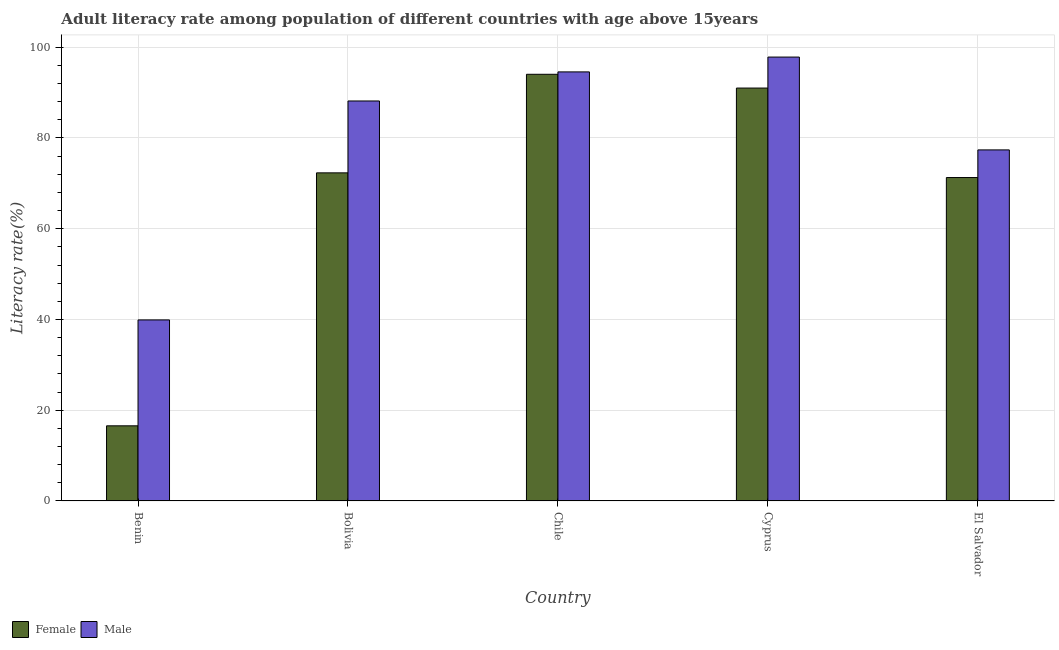How many bars are there on the 4th tick from the left?
Give a very brief answer. 2. How many bars are there on the 1st tick from the right?
Provide a succinct answer. 2. In how many cases, is the number of bars for a given country not equal to the number of legend labels?
Offer a terse response. 0. What is the female adult literacy rate in Chile?
Give a very brief answer. 94.04. Across all countries, what is the maximum female adult literacy rate?
Ensure brevity in your answer.  94.04. Across all countries, what is the minimum male adult literacy rate?
Keep it short and to the point. 39.9. In which country was the male adult literacy rate maximum?
Give a very brief answer. Cyprus. In which country was the male adult literacy rate minimum?
Make the answer very short. Benin. What is the total male adult literacy rate in the graph?
Your answer should be compact. 397.82. What is the difference between the male adult literacy rate in Benin and that in Bolivia?
Your answer should be compact. -48.25. What is the difference between the female adult literacy rate in Bolivia and the male adult literacy rate in El Salvador?
Your answer should be very brief. -5.06. What is the average male adult literacy rate per country?
Offer a terse response. 79.56. What is the difference between the female adult literacy rate and male adult literacy rate in Benin?
Provide a short and direct response. -23.34. In how many countries, is the male adult literacy rate greater than 48 %?
Give a very brief answer. 4. What is the ratio of the female adult literacy rate in Bolivia to that in Cyprus?
Your response must be concise. 0.79. Is the female adult literacy rate in Bolivia less than that in Chile?
Ensure brevity in your answer.  Yes. What is the difference between the highest and the second highest male adult literacy rate?
Your response must be concise. 3.27. What is the difference between the highest and the lowest male adult literacy rate?
Give a very brief answer. 57.93. In how many countries, is the female adult literacy rate greater than the average female adult literacy rate taken over all countries?
Your response must be concise. 4. How many countries are there in the graph?
Your answer should be very brief. 5. What is the difference between two consecutive major ticks on the Y-axis?
Provide a succinct answer. 20. Where does the legend appear in the graph?
Your response must be concise. Bottom left. How are the legend labels stacked?
Your answer should be very brief. Horizontal. What is the title of the graph?
Ensure brevity in your answer.  Adult literacy rate among population of different countries with age above 15years. What is the label or title of the Y-axis?
Provide a succinct answer. Literacy rate(%). What is the Literacy rate(%) in Female in Benin?
Your response must be concise. 16.57. What is the Literacy rate(%) in Male in Benin?
Your answer should be compact. 39.9. What is the Literacy rate(%) in Female in Bolivia?
Provide a short and direct response. 72.31. What is the Literacy rate(%) in Male in Bolivia?
Your answer should be compact. 88.16. What is the Literacy rate(%) of Female in Chile?
Provide a short and direct response. 94.04. What is the Literacy rate(%) of Male in Chile?
Give a very brief answer. 94.56. What is the Literacy rate(%) of Female in Cyprus?
Keep it short and to the point. 91. What is the Literacy rate(%) of Male in Cyprus?
Offer a very short reply. 97.83. What is the Literacy rate(%) in Female in El Salvador?
Your response must be concise. 71.28. What is the Literacy rate(%) in Male in El Salvador?
Your answer should be very brief. 77.37. Across all countries, what is the maximum Literacy rate(%) of Female?
Give a very brief answer. 94.04. Across all countries, what is the maximum Literacy rate(%) of Male?
Offer a very short reply. 97.83. Across all countries, what is the minimum Literacy rate(%) in Female?
Offer a very short reply. 16.57. Across all countries, what is the minimum Literacy rate(%) in Male?
Offer a very short reply. 39.9. What is the total Literacy rate(%) of Female in the graph?
Give a very brief answer. 345.2. What is the total Literacy rate(%) of Male in the graph?
Your response must be concise. 397.82. What is the difference between the Literacy rate(%) of Female in Benin and that in Bolivia?
Give a very brief answer. -55.75. What is the difference between the Literacy rate(%) in Male in Benin and that in Bolivia?
Your answer should be very brief. -48.25. What is the difference between the Literacy rate(%) of Female in Benin and that in Chile?
Provide a short and direct response. -77.47. What is the difference between the Literacy rate(%) of Male in Benin and that in Chile?
Ensure brevity in your answer.  -54.66. What is the difference between the Literacy rate(%) of Female in Benin and that in Cyprus?
Offer a terse response. -74.44. What is the difference between the Literacy rate(%) of Male in Benin and that in Cyprus?
Make the answer very short. -57.93. What is the difference between the Literacy rate(%) in Female in Benin and that in El Salvador?
Make the answer very short. -54.72. What is the difference between the Literacy rate(%) in Male in Benin and that in El Salvador?
Provide a succinct answer. -37.47. What is the difference between the Literacy rate(%) in Female in Bolivia and that in Chile?
Provide a succinct answer. -21.72. What is the difference between the Literacy rate(%) in Male in Bolivia and that in Chile?
Give a very brief answer. -6.41. What is the difference between the Literacy rate(%) of Female in Bolivia and that in Cyprus?
Your response must be concise. -18.69. What is the difference between the Literacy rate(%) of Male in Bolivia and that in Cyprus?
Your response must be concise. -9.68. What is the difference between the Literacy rate(%) of Female in Bolivia and that in El Salvador?
Ensure brevity in your answer.  1.03. What is the difference between the Literacy rate(%) of Male in Bolivia and that in El Salvador?
Make the answer very short. 10.78. What is the difference between the Literacy rate(%) in Female in Chile and that in Cyprus?
Provide a short and direct response. 3.03. What is the difference between the Literacy rate(%) in Male in Chile and that in Cyprus?
Provide a short and direct response. -3.27. What is the difference between the Literacy rate(%) of Female in Chile and that in El Salvador?
Your answer should be very brief. 22.76. What is the difference between the Literacy rate(%) in Male in Chile and that in El Salvador?
Provide a succinct answer. 17.19. What is the difference between the Literacy rate(%) of Female in Cyprus and that in El Salvador?
Offer a terse response. 19.72. What is the difference between the Literacy rate(%) in Male in Cyprus and that in El Salvador?
Your answer should be very brief. 20.46. What is the difference between the Literacy rate(%) in Female in Benin and the Literacy rate(%) in Male in Bolivia?
Provide a succinct answer. -71.59. What is the difference between the Literacy rate(%) of Female in Benin and the Literacy rate(%) of Male in Chile?
Ensure brevity in your answer.  -78. What is the difference between the Literacy rate(%) of Female in Benin and the Literacy rate(%) of Male in Cyprus?
Your answer should be compact. -81.27. What is the difference between the Literacy rate(%) in Female in Benin and the Literacy rate(%) in Male in El Salvador?
Offer a terse response. -60.81. What is the difference between the Literacy rate(%) of Female in Bolivia and the Literacy rate(%) of Male in Chile?
Provide a succinct answer. -22.25. What is the difference between the Literacy rate(%) in Female in Bolivia and the Literacy rate(%) in Male in Cyprus?
Your response must be concise. -25.52. What is the difference between the Literacy rate(%) of Female in Bolivia and the Literacy rate(%) of Male in El Salvador?
Your response must be concise. -5.06. What is the difference between the Literacy rate(%) of Female in Chile and the Literacy rate(%) of Male in Cyprus?
Offer a very short reply. -3.79. What is the difference between the Literacy rate(%) in Female in Chile and the Literacy rate(%) in Male in El Salvador?
Make the answer very short. 16.66. What is the difference between the Literacy rate(%) of Female in Cyprus and the Literacy rate(%) of Male in El Salvador?
Your answer should be compact. 13.63. What is the average Literacy rate(%) in Female per country?
Ensure brevity in your answer.  69.04. What is the average Literacy rate(%) of Male per country?
Your answer should be compact. 79.56. What is the difference between the Literacy rate(%) in Female and Literacy rate(%) in Male in Benin?
Ensure brevity in your answer.  -23.34. What is the difference between the Literacy rate(%) in Female and Literacy rate(%) in Male in Bolivia?
Your answer should be compact. -15.84. What is the difference between the Literacy rate(%) of Female and Literacy rate(%) of Male in Chile?
Offer a very short reply. -0.53. What is the difference between the Literacy rate(%) in Female and Literacy rate(%) in Male in Cyprus?
Provide a succinct answer. -6.83. What is the difference between the Literacy rate(%) of Female and Literacy rate(%) of Male in El Salvador?
Make the answer very short. -6.09. What is the ratio of the Literacy rate(%) in Female in Benin to that in Bolivia?
Give a very brief answer. 0.23. What is the ratio of the Literacy rate(%) of Male in Benin to that in Bolivia?
Offer a very short reply. 0.45. What is the ratio of the Literacy rate(%) in Female in Benin to that in Chile?
Offer a very short reply. 0.18. What is the ratio of the Literacy rate(%) in Male in Benin to that in Chile?
Provide a short and direct response. 0.42. What is the ratio of the Literacy rate(%) of Female in Benin to that in Cyprus?
Your answer should be compact. 0.18. What is the ratio of the Literacy rate(%) in Male in Benin to that in Cyprus?
Make the answer very short. 0.41. What is the ratio of the Literacy rate(%) in Female in Benin to that in El Salvador?
Your response must be concise. 0.23. What is the ratio of the Literacy rate(%) of Male in Benin to that in El Salvador?
Your response must be concise. 0.52. What is the ratio of the Literacy rate(%) of Female in Bolivia to that in Chile?
Provide a succinct answer. 0.77. What is the ratio of the Literacy rate(%) in Male in Bolivia to that in Chile?
Provide a short and direct response. 0.93. What is the ratio of the Literacy rate(%) in Female in Bolivia to that in Cyprus?
Provide a succinct answer. 0.79. What is the ratio of the Literacy rate(%) of Male in Bolivia to that in Cyprus?
Your answer should be very brief. 0.9. What is the ratio of the Literacy rate(%) in Female in Bolivia to that in El Salvador?
Keep it short and to the point. 1.01. What is the ratio of the Literacy rate(%) of Male in Bolivia to that in El Salvador?
Make the answer very short. 1.14. What is the ratio of the Literacy rate(%) in Female in Chile to that in Cyprus?
Your answer should be compact. 1.03. What is the ratio of the Literacy rate(%) of Male in Chile to that in Cyprus?
Your answer should be very brief. 0.97. What is the ratio of the Literacy rate(%) in Female in Chile to that in El Salvador?
Offer a terse response. 1.32. What is the ratio of the Literacy rate(%) of Male in Chile to that in El Salvador?
Provide a succinct answer. 1.22. What is the ratio of the Literacy rate(%) in Female in Cyprus to that in El Salvador?
Ensure brevity in your answer.  1.28. What is the ratio of the Literacy rate(%) in Male in Cyprus to that in El Salvador?
Make the answer very short. 1.26. What is the difference between the highest and the second highest Literacy rate(%) in Female?
Provide a succinct answer. 3.03. What is the difference between the highest and the second highest Literacy rate(%) of Male?
Offer a very short reply. 3.27. What is the difference between the highest and the lowest Literacy rate(%) of Female?
Keep it short and to the point. 77.47. What is the difference between the highest and the lowest Literacy rate(%) in Male?
Your answer should be compact. 57.93. 